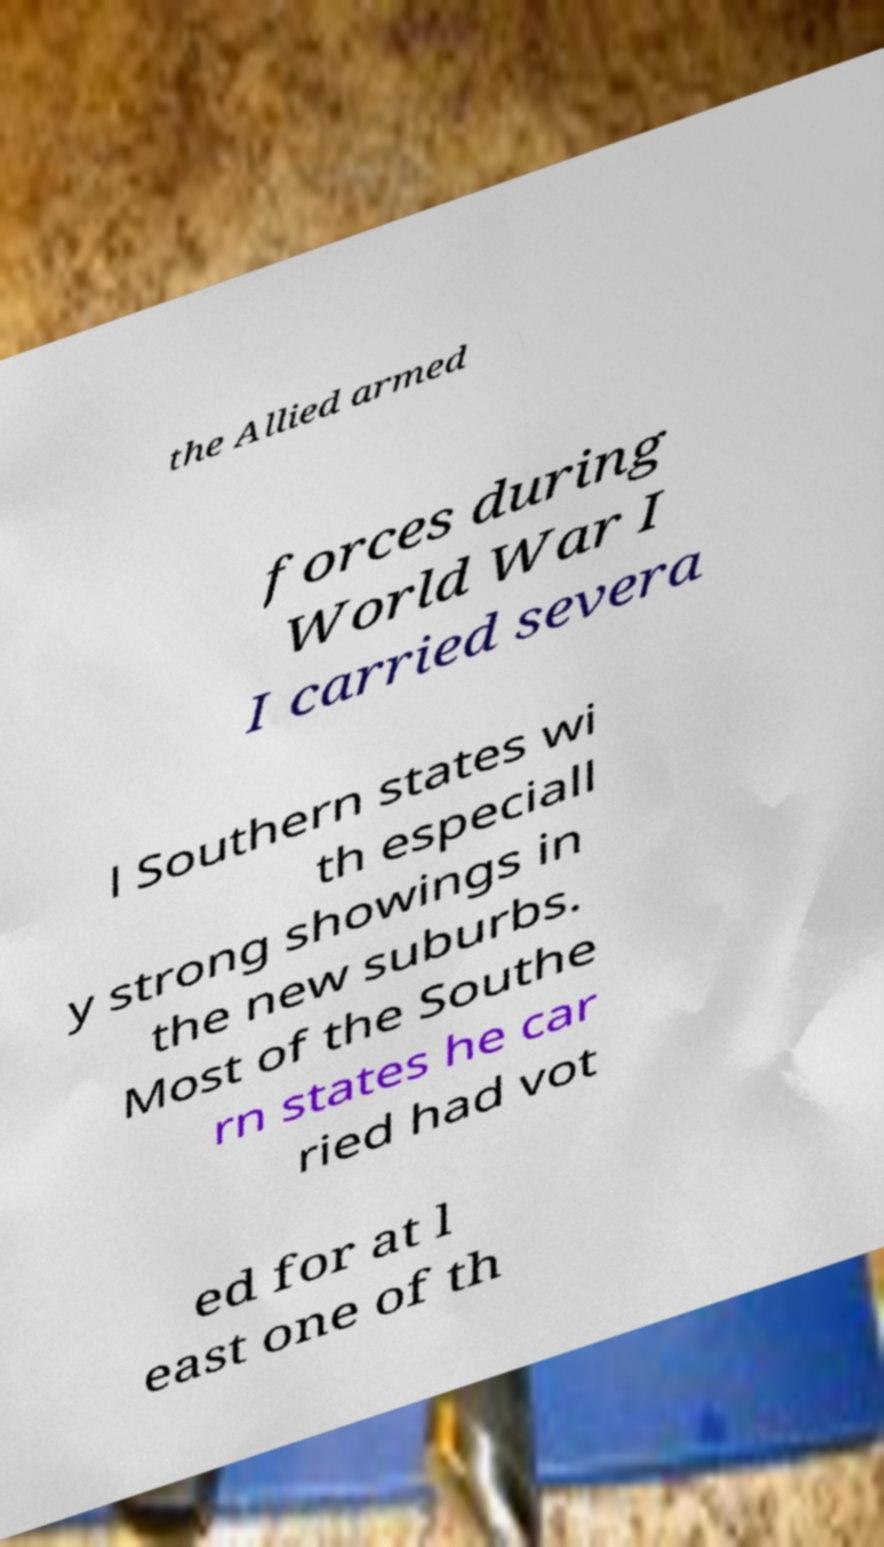What messages or text are displayed in this image? I need them in a readable, typed format. the Allied armed forces during World War I I carried severa l Southern states wi th especiall y strong showings in the new suburbs. Most of the Southe rn states he car ried had vot ed for at l east one of th 